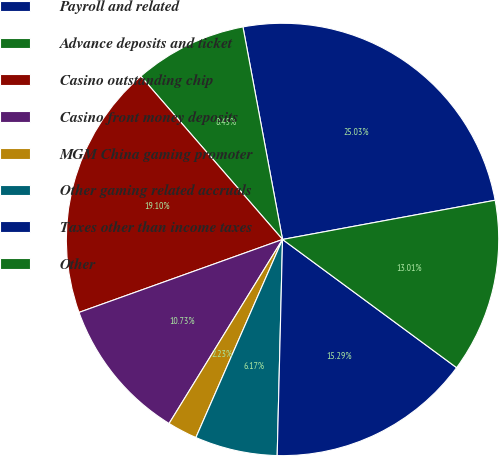Convert chart to OTSL. <chart><loc_0><loc_0><loc_500><loc_500><pie_chart><fcel>Payroll and related<fcel>Advance deposits and ticket<fcel>Casino outstanding chip<fcel>Casino front money deposits<fcel>MGM China gaming promoter<fcel>Other gaming related accruals<fcel>Taxes other than income taxes<fcel>Other<nl><fcel>25.03%<fcel>8.45%<fcel>19.1%<fcel>10.73%<fcel>2.23%<fcel>6.17%<fcel>15.29%<fcel>13.01%<nl></chart> 